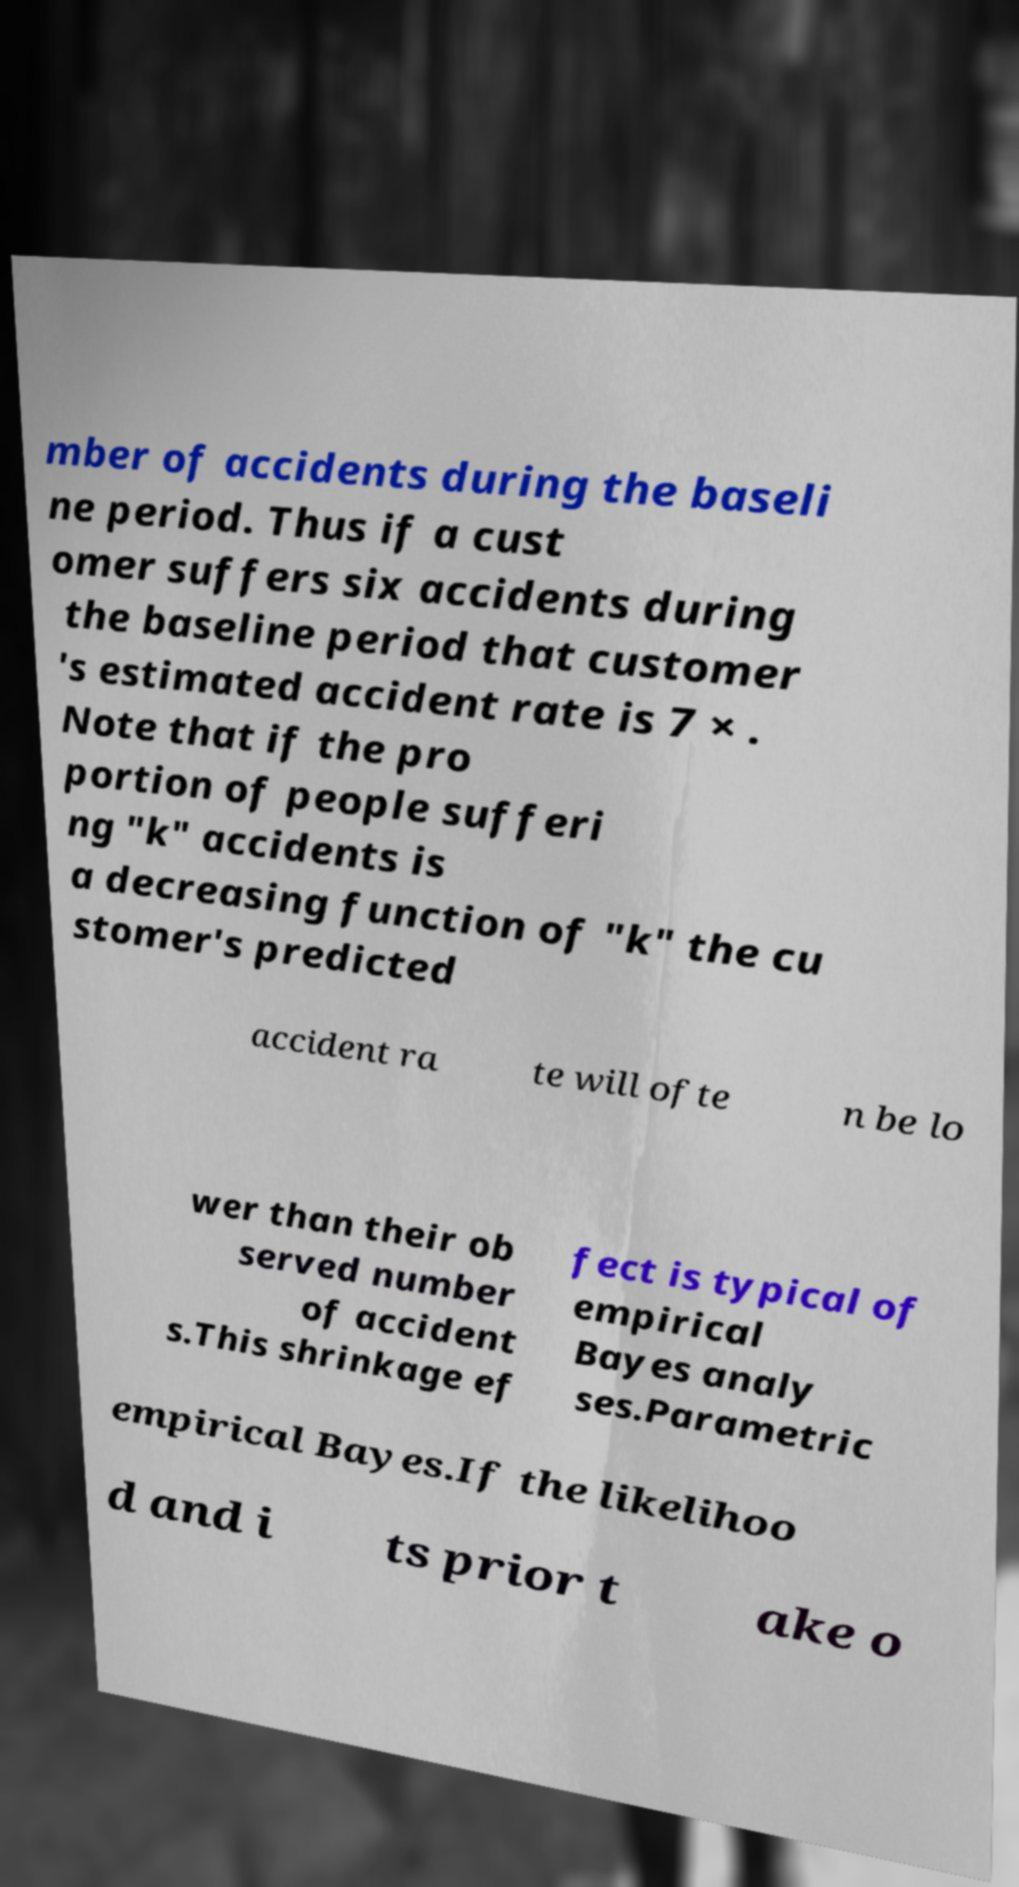For documentation purposes, I need the text within this image transcribed. Could you provide that? mber of accidents during the baseli ne period. Thus if a cust omer suffers six accidents during the baseline period that customer 's estimated accident rate is 7 × . Note that if the pro portion of people sufferi ng "k" accidents is a decreasing function of "k" the cu stomer's predicted accident ra te will ofte n be lo wer than their ob served number of accident s.This shrinkage ef fect is typical of empirical Bayes analy ses.Parametric empirical Bayes.If the likelihoo d and i ts prior t ake o 